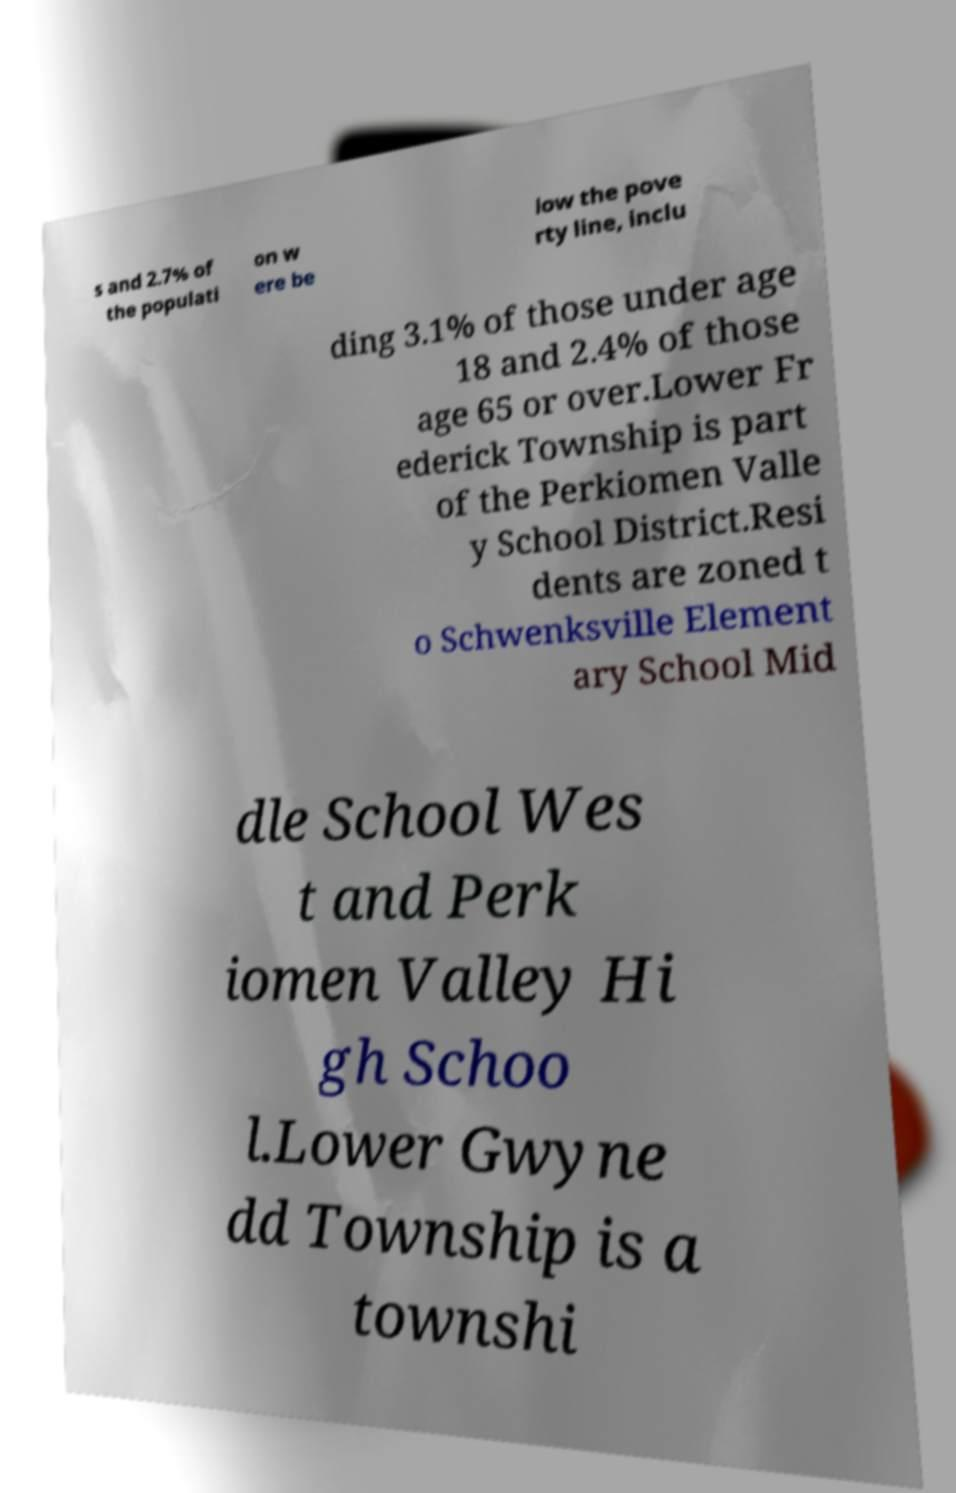There's text embedded in this image that I need extracted. Can you transcribe it verbatim? s and 2.7% of the populati on w ere be low the pove rty line, inclu ding 3.1% of those under age 18 and 2.4% of those age 65 or over.Lower Fr ederick Township is part of the Perkiomen Valle y School District.Resi dents are zoned t o Schwenksville Element ary School Mid dle School Wes t and Perk iomen Valley Hi gh Schoo l.Lower Gwyne dd Township is a townshi 